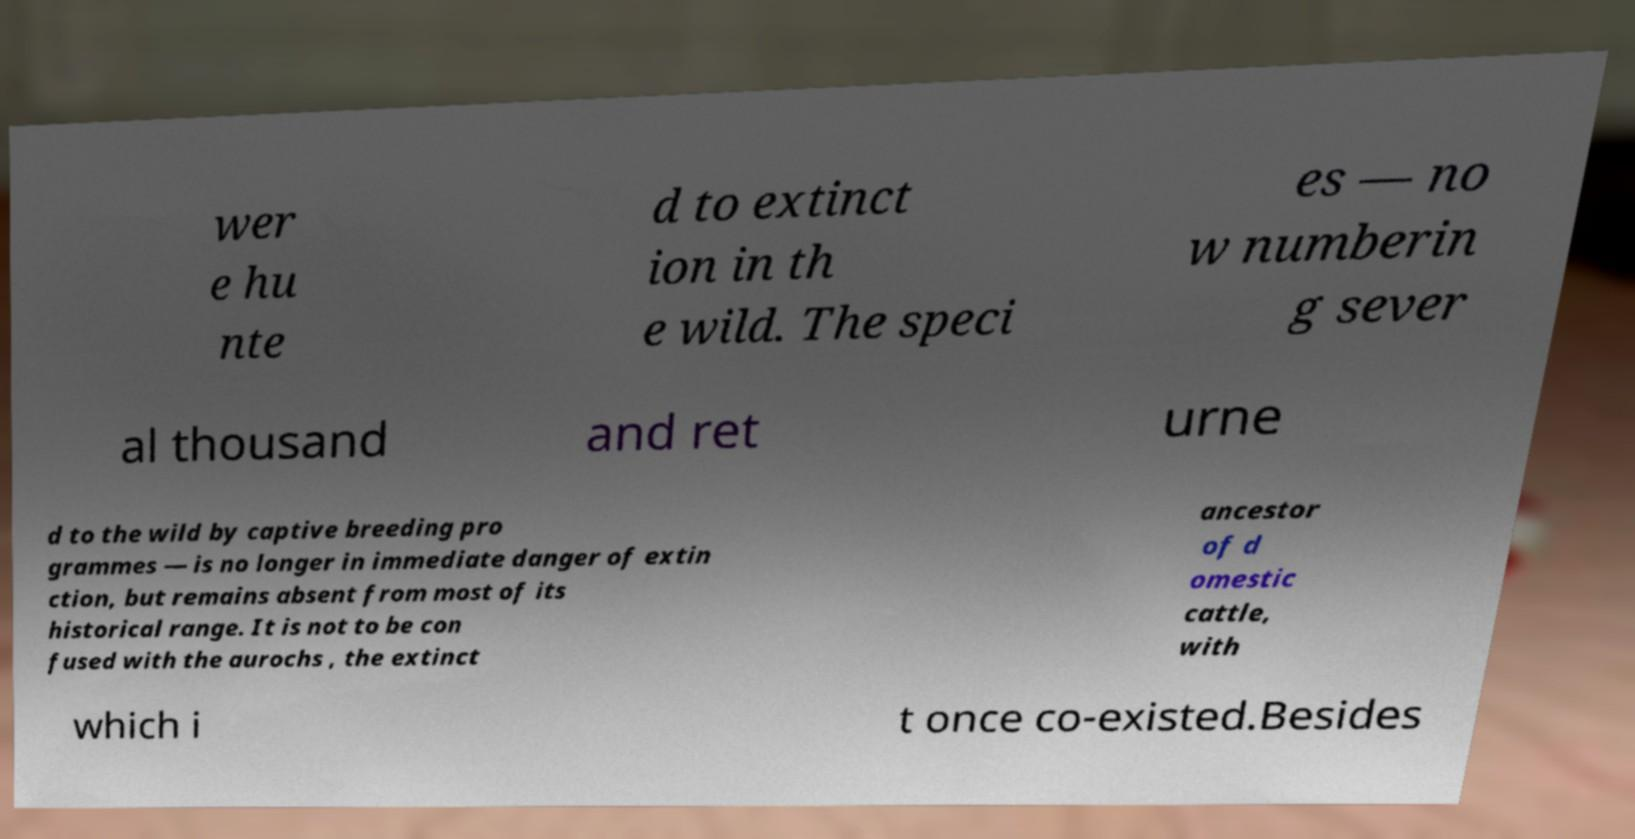Can you accurately transcribe the text from the provided image for me? wer e hu nte d to extinct ion in th e wild. The speci es — no w numberin g sever al thousand and ret urne d to the wild by captive breeding pro grammes — is no longer in immediate danger of extin ction, but remains absent from most of its historical range. It is not to be con fused with the aurochs , the extinct ancestor of d omestic cattle, with which i t once co-existed.Besides 